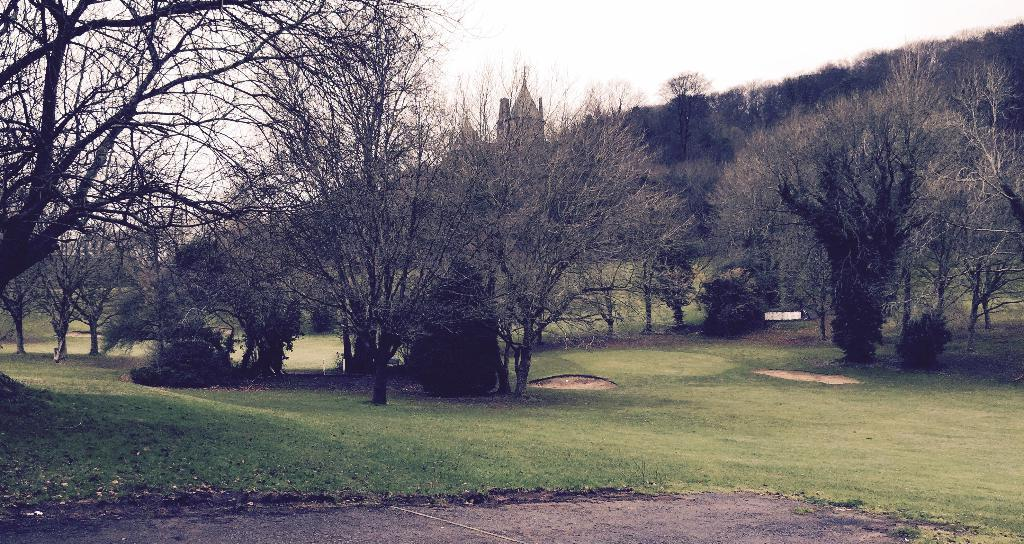What type of surface is visible in the image? There is a grass surface in the image. What can be seen on the grass surface? There are dried trees on the grass surface. What structure is visible in the image? There is a building visible in the image. What is the appearance of the building's top? The building has a painted top. What is visible in the background of the image? The sky is visible in the background of the image. How many kittens are wearing collars in the image? There are no kittens or collars present in the image. What type of whip is being used to paint the building's top? There is no whip present in the image, and the building's top is painted, not whipped. 